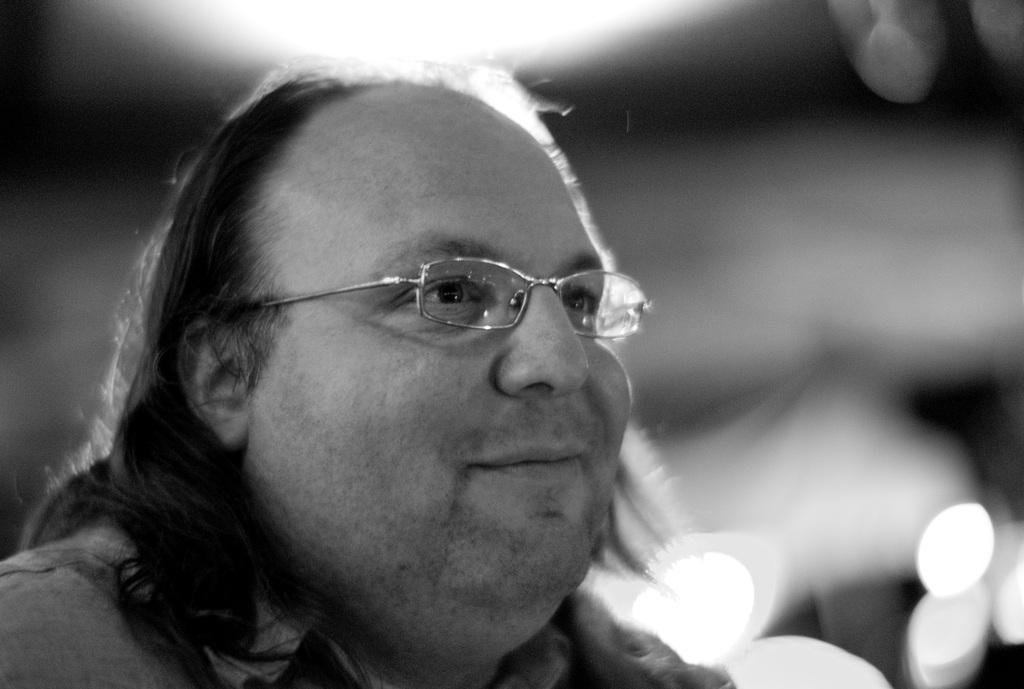What is the color scheme of the image? The image is black and white. Can you describe the main subject in the image? There is a person in the image, specifically a man. What part of the man is visible in the image? Only the man's face is visible in the image. What accessory is the man wearing in the image? The man is wearing glasses (specs) in the image. What verse is the man reciting in the image? There is no indication in the image that the man is reciting a verse, as only his face is visible. 